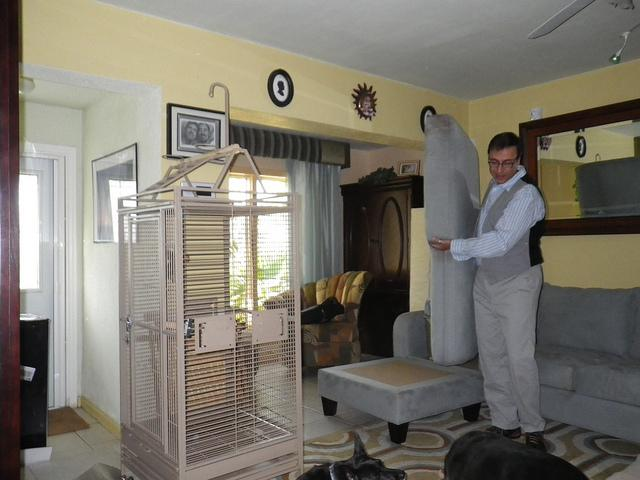Pet care Helpline number?

Choices:
A) 966
B) 952
C) 822
D) 911 952 